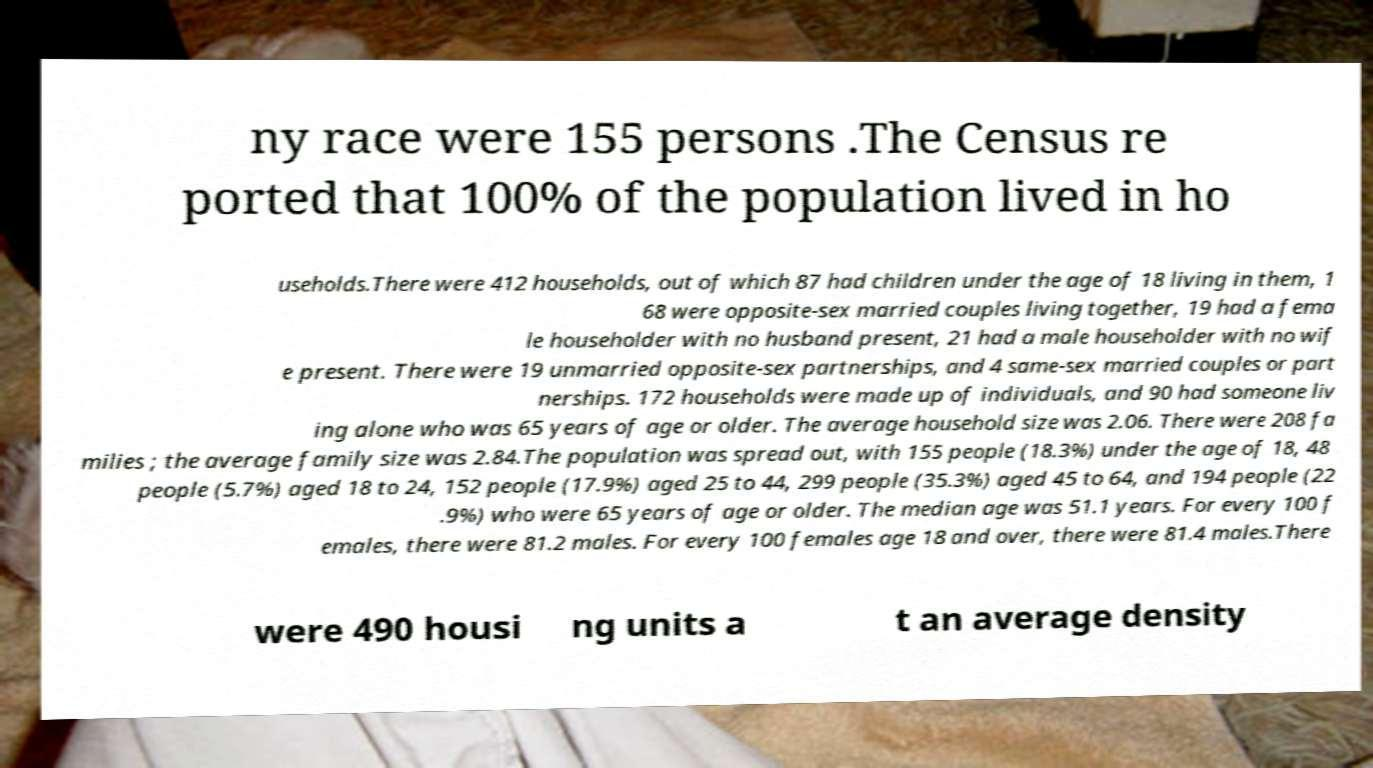Could you assist in decoding the text presented in this image and type it out clearly? ny race were 155 persons .The Census re ported that 100% of the population lived in ho useholds.There were 412 households, out of which 87 had children under the age of 18 living in them, 1 68 were opposite-sex married couples living together, 19 had a fema le householder with no husband present, 21 had a male householder with no wif e present. There were 19 unmarried opposite-sex partnerships, and 4 same-sex married couples or part nerships. 172 households were made up of individuals, and 90 had someone liv ing alone who was 65 years of age or older. The average household size was 2.06. There were 208 fa milies ; the average family size was 2.84.The population was spread out, with 155 people (18.3%) under the age of 18, 48 people (5.7%) aged 18 to 24, 152 people (17.9%) aged 25 to 44, 299 people (35.3%) aged 45 to 64, and 194 people (22 .9%) who were 65 years of age or older. The median age was 51.1 years. For every 100 f emales, there were 81.2 males. For every 100 females age 18 and over, there were 81.4 males.There were 490 housi ng units a t an average density 